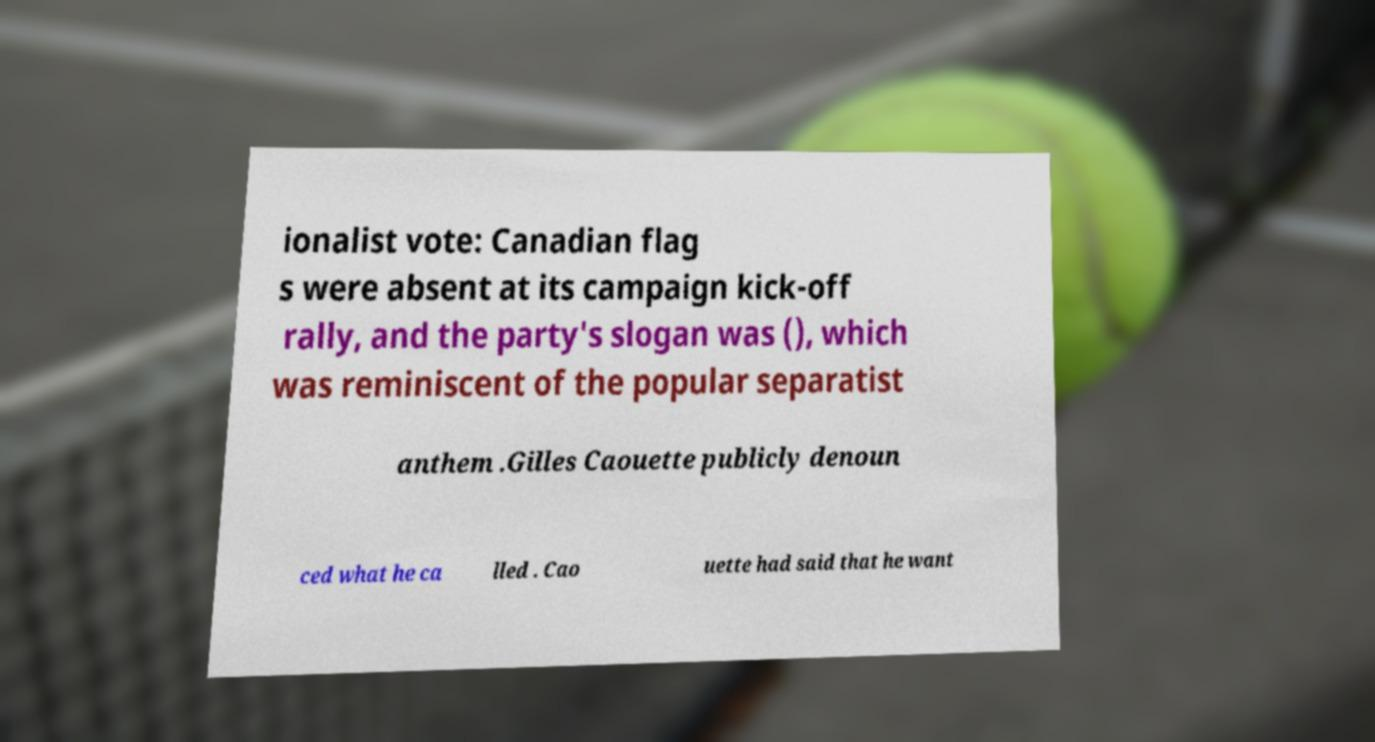I need the written content from this picture converted into text. Can you do that? ionalist vote: Canadian flag s were absent at its campaign kick-off rally, and the party's slogan was (), which was reminiscent of the popular separatist anthem .Gilles Caouette publicly denoun ced what he ca lled . Cao uette had said that he want 